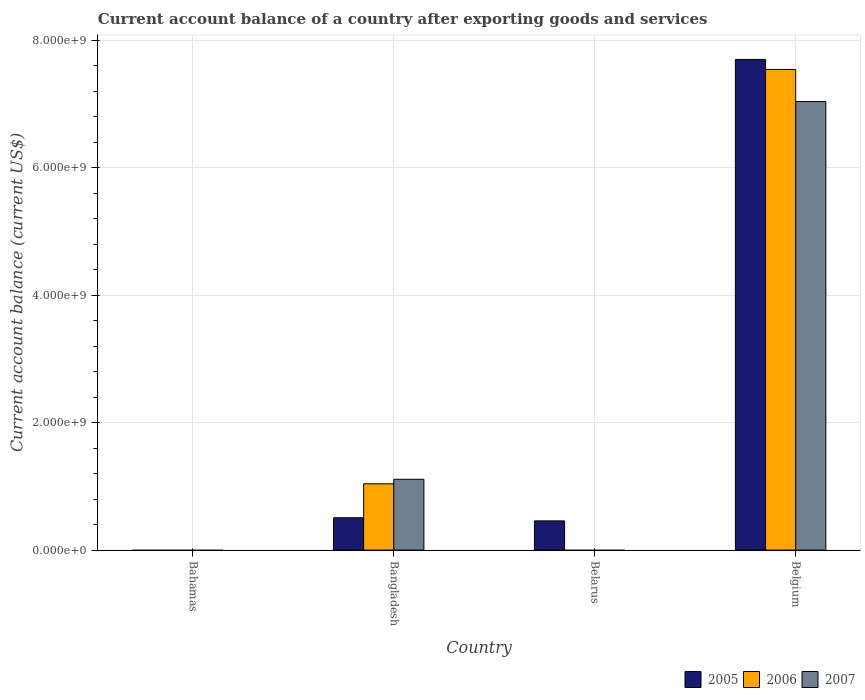How many different coloured bars are there?
Offer a very short reply. 3. Are the number of bars per tick equal to the number of legend labels?
Your answer should be very brief. No. Are the number of bars on each tick of the X-axis equal?
Your response must be concise. No. How many bars are there on the 2nd tick from the right?
Ensure brevity in your answer.  1. What is the label of the 1st group of bars from the left?
Keep it short and to the point. Bahamas. What is the account balance in 2007 in Bangladesh?
Provide a short and direct response. 1.11e+09. Across all countries, what is the maximum account balance in 2007?
Your response must be concise. 7.04e+09. Across all countries, what is the minimum account balance in 2006?
Offer a terse response. 0. What is the total account balance in 2007 in the graph?
Offer a very short reply. 8.15e+09. What is the difference between the account balance in 2007 in Bangladesh and that in Belgium?
Give a very brief answer. -5.93e+09. What is the difference between the account balance in 2005 in Bangladesh and the account balance in 2007 in Belarus?
Provide a short and direct response. 5.08e+08. What is the average account balance in 2006 per country?
Your answer should be very brief. 2.15e+09. What is the difference between the account balance of/in 2005 and account balance of/in 2006 in Bangladesh?
Give a very brief answer. -5.33e+08. Is the account balance in 2005 in Bangladesh less than that in Belarus?
Your response must be concise. No. Is the difference between the account balance in 2005 in Bangladesh and Belgium greater than the difference between the account balance in 2006 in Bangladesh and Belgium?
Give a very brief answer. No. What is the difference between the highest and the second highest account balance in 2005?
Your answer should be compact. -4.91e+07. What is the difference between the highest and the lowest account balance in 2005?
Make the answer very short. 7.70e+09. In how many countries, is the account balance in 2007 greater than the average account balance in 2007 taken over all countries?
Give a very brief answer. 1. Is the sum of the account balance in 2005 in Belarus and Belgium greater than the maximum account balance in 2006 across all countries?
Provide a succinct answer. Yes. How many bars are there?
Offer a very short reply. 7. Are all the bars in the graph horizontal?
Offer a terse response. No. How many countries are there in the graph?
Provide a short and direct response. 4. What is the difference between two consecutive major ticks on the Y-axis?
Your answer should be very brief. 2.00e+09. Are the values on the major ticks of Y-axis written in scientific E-notation?
Provide a short and direct response. Yes. Does the graph contain any zero values?
Make the answer very short. Yes. Where does the legend appear in the graph?
Give a very brief answer. Bottom right. How are the legend labels stacked?
Offer a very short reply. Horizontal. What is the title of the graph?
Your answer should be very brief. Current account balance of a country after exporting goods and services. Does "1998" appear as one of the legend labels in the graph?
Make the answer very short. No. What is the label or title of the Y-axis?
Ensure brevity in your answer.  Current account balance (current US$). What is the Current account balance (current US$) in 2005 in Bangladesh?
Your answer should be compact. 5.08e+08. What is the Current account balance (current US$) of 2006 in Bangladesh?
Make the answer very short. 1.04e+09. What is the Current account balance (current US$) of 2007 in Bangladesh?
Give a very brief answer. 1.11e+09. What is the Current account balance (current US$) in 2005 in Belarus?
Ensure brevity in your answer.  4.59e+08. What is the Current account balance (current US$) in 2005 in Belgium?
Offer a very short reply. 7.70e+09. What is the Current account balance (current US$) of 2006 in Belgium?
Keep it short and to the point. 7.55e+09. What is the Current account balance (current US$) of 2007 in Belgium?
Make the answer very short. 7.04e+09. Across all countries, what is the maximum Current account balance (current US$) of 2005?
Provide a succinct answer. 7.70e+09. Across all countries, what is the maximum Current account balance (current US$) in 2006?
Offer a terse response. 7.55e+09. Across all countries, what is the maximum Current account balance (current US$) of 2007?
Your answer should be very brief. 7.04e+09. Across all countries, what is the minimum Current account balance (current US$) in 2007?
Make the answer very short. 0. What is the total Current account balance (current US$) in 2005 in the graph?
Give a very brief answer. 8.67e+09. What is the total Current account balance (current US$) of 2006 in the graph?
Make the answer very short. 8.59e+09. What is the total Current account balance (current US$) of 2007 in the graph?
Keep it short and to the point. 8.15e+09. What is the difference between the Current account balance (current US$) in 2005 in Bangladesh and that in Belarus?
Your answer should be compact. 4.91e+07. What is the difference between the Current account balance (current US$) of 2005 in Bangladesh and that in Belgium?
Ensure brevity in your answer.  -7.19e+09. What is the difference between the Current account balance (current US$) of 2006 in Bangladesh and that in Belgium?
Provide a succinct answer. -6.50e+09. What is the difference between the Current account balance (current US$) of 2007 in Bangladesh and that in Belgium?
Keep it short and to the point. -5.93e+09. What is the difference between the Current account balance (current US$) of 2005 in Belarus and that in Belgium?
Your response must be concise. -7.24e+09. What is the difference between the Current account balance (current US$) in 2005 in Bangladesh and the Current account balance (current US$) in 2006 in Belgium?
Offer a terse response. -7.04e+09. What is the difference between the Current account balance (current US$) of 2005 in Bangladesh and the Current account balance (current US$) of 2007 in Belgium?
Ensure brevity in your answer.  -6.53e+09. What is the difference between the Current account balance (current US$) of 2006 in Bangladesh and the Current account balance (current US$) of 2007 in Belgium?
Keep it short and to the point. -6.00e+09. What is the difference between the Current account balance (current US$) in 2005 in Belarus and the Current account balance (current US$) in 2006 in Belgium?
Keep it short and to the point. -7.09e+09. What is the difference between the Current account balance (current US$) of 2005 in Belarus and the Current account balance (current US$) of 2007 in Belgium?
Make the answer very short. -6.58e+09. What is the average Current account balance (current US$) of 2005 per country?
Keep it short and to the point. 2.17e+09. What is the average Current account balance (current US$) of 2006 per country?
Offer a very short reply. 2.15e+09. What is the average Current account balance (current US$) in 2007 per country?
Offer a very short reply. 2.04e+09. What is the difference between the Current account balance (current US$) in 2005 and Current account balance (current US$) in 2006 in Bangladesh?
Keep it short and to the point. -5.33e+08. What is the difference between the Current account balance (current US$) in 2005 and Current account balance (current US$) in 2007 in Bangladesh?
Provide a succinct answer. -6.04e+08. What is the difference between the Current account balance (current US$) in 2006 and Current account balance (current US$) in 2007 in Bangladesh?
Make the answer very short. -7.13e+07. What is the difference between the Current account balance (current US$) of 2005 and Current account balance (current US$) of 2006 in Belgium?
Offer a very short reply. 1.58e+08. What is the difference between the Current account balance (current US$) of 2005 and Current account balance (current US$) of 2007 in Belgium?
Offer a very short reply. 6.61e+08. What is the difference between the Current account balance (current US$) of 2006 and Current account balance (current US$) of 2007 in Belgium?
Provide a succinct answer. 5.04e+08. What is the ratio of the Current account balance (current US$) in 2005 in Bangladesh to that in Belarus?
Keep it short and to the point. 1.11. What is the ratio of the Current account balance (current US$) in 2005 in Bangladesh to that in Belgium?
Provide a short and direct response. 0.07. What is the ratio of the Current account balance (current US$) in 2006 in Bangladesh to that in Belgium?
Give a very brief answer. 0.14. What is the ratio of the Current account balance (current US$) in 2007 in Bangladesh to that in Belgium?
Ensure brevity in your answer.  0.16. What is the ratio of the Current account balance (current US$) in 2005 in Belarus to that in Belgium?
Your answer should be very brief. 0.06. What is the difference between the highest and the second highest Current account balance (current US$) in 2005?
Provide a short and direct response. 7.19e+09. What is the difference between the highest and the lowest Current account balance (current US$) in 2005?
Ensure brevity in your answer.  7.70e+09. What is the difference between the highest and the lowest Current account balance (current US$) in 2006?
Keep it short and to the point. 7.55e+09. What is the difference between the highest and the lowest Current account balance (current US$) in 2007?
Your answer should be compact. 7.04e+09. 